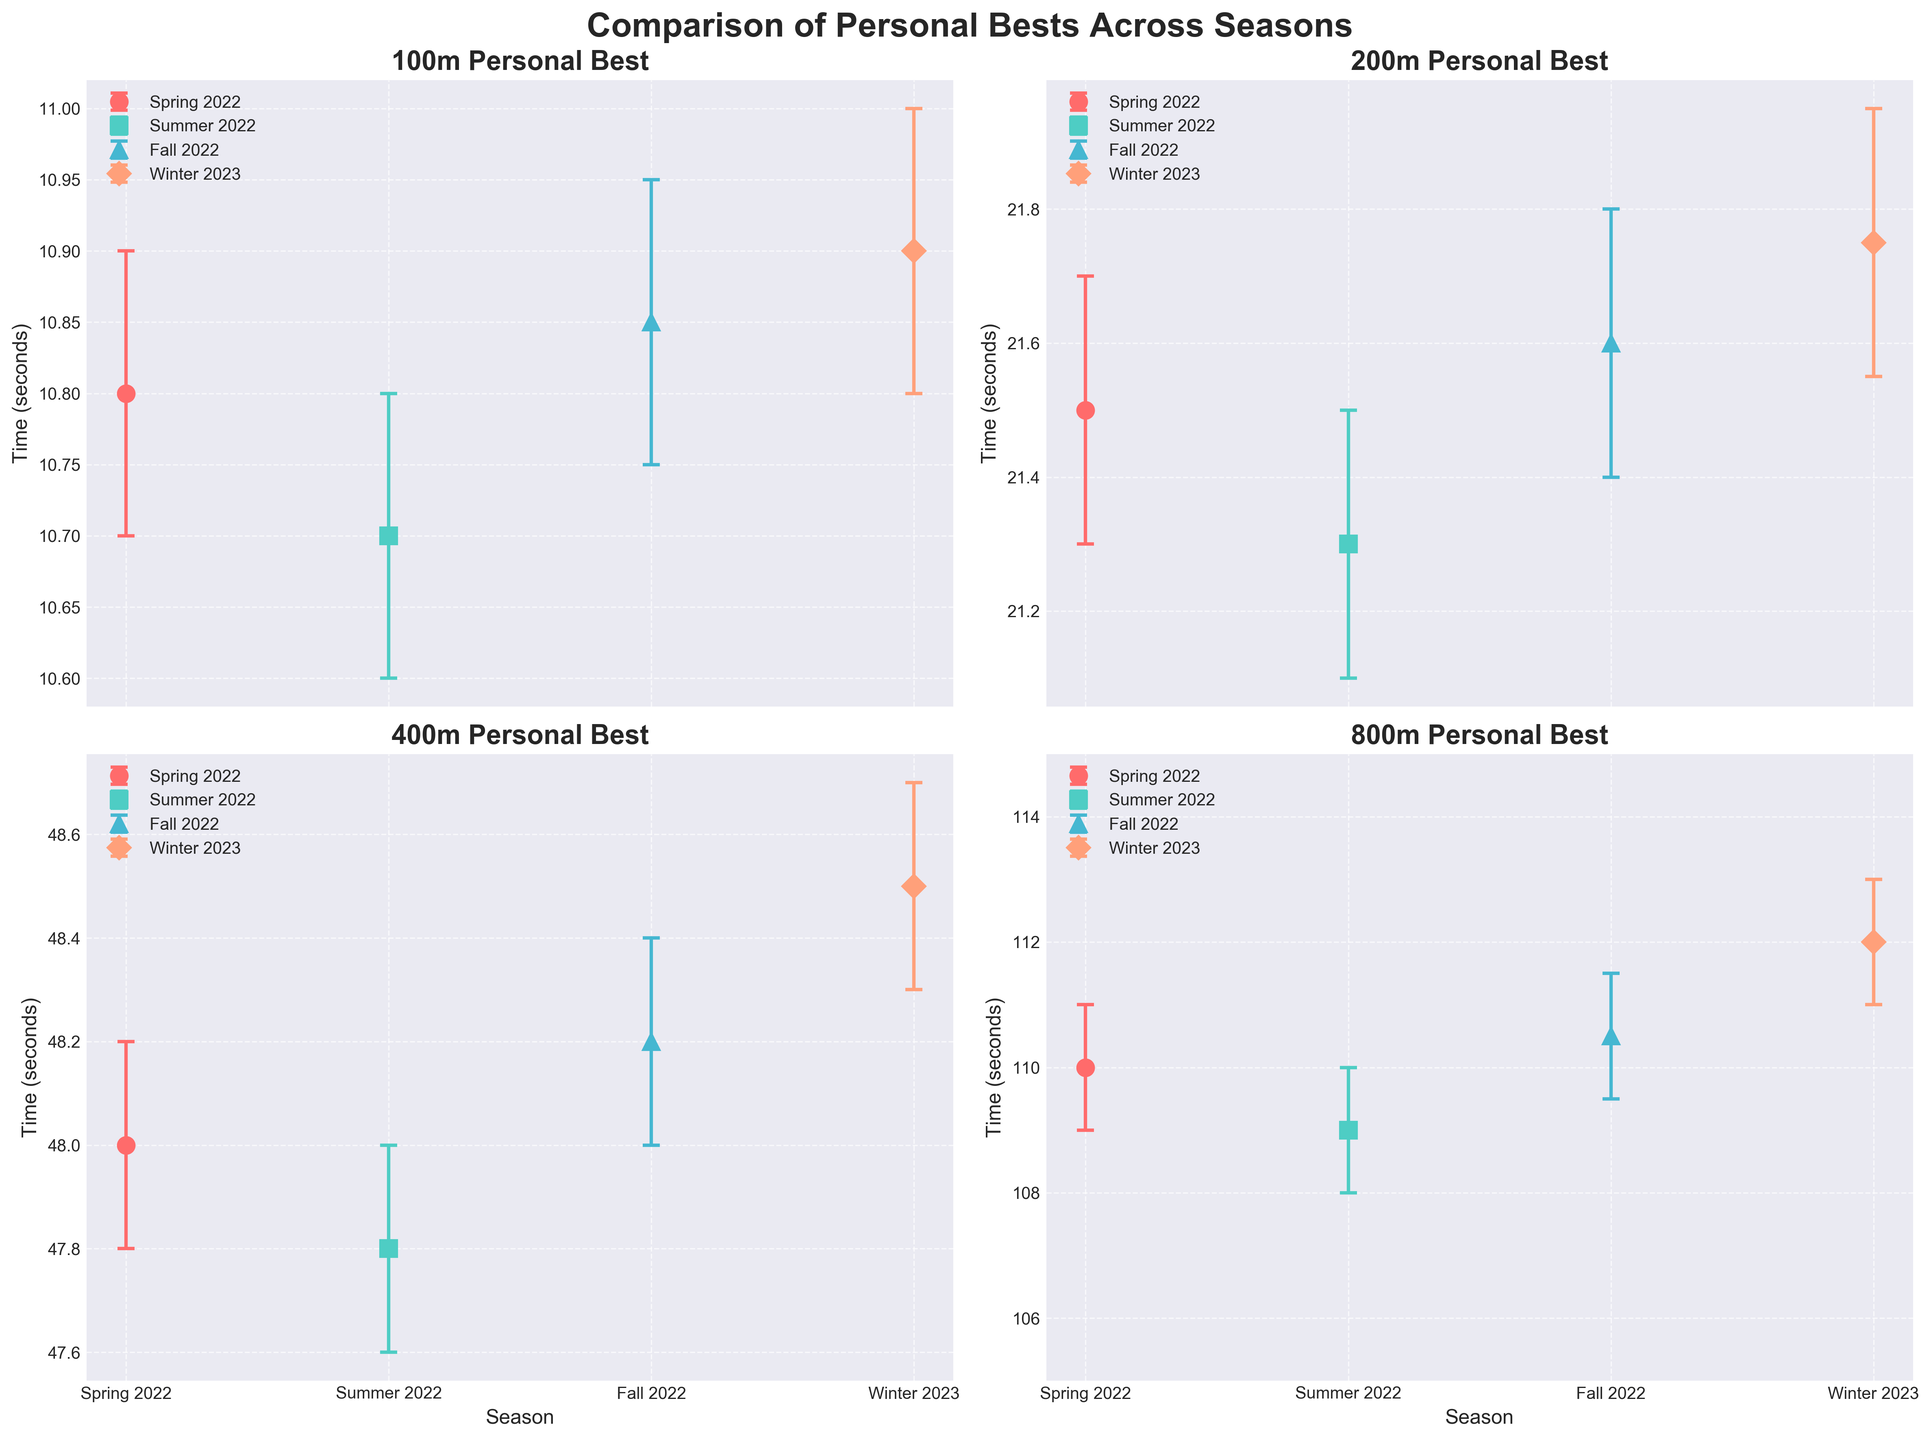What's the primary title of the figure? The main title is located above all subplots, which summarizes the content of the figure. It states 'Comparison of Personal Bests Across Seasons', reflecting the purpose of the figure which is to compare timings across different events and seasons.
Answer: Comparison of Personal Bests Across Seasons How many events are compared in the figure? Each subplot represents one event, and there are four subplots in total. Therefore, four different events are compared.
Answer: Four Which season has the best personal best time for the 200m event? By comparing the error bars and markers within the subplot for the 200m event, Summer 2022 has the lowest time at 21.30 sec, indicating the best personal best.
Answer: Summer 2022 What is the overall trend in personal best times for the 100m event from Spring 2022 to Winter 2023? Checking the 100m subplot, the personal best times slightly decrease in Summer 2022 to 10.70 sec, increase in Fall 2022 to 10.85 sec, and rise further in Winter 2023 to 10.90 sec, indicating a general worsening overtime.
Answer: Times worsening Which event shows the widest confidence interval in Winter 2023? By comparing the range of error bars for Winter 2023 in each subplot, the 800m event subplot shows the widest confidence interval with a range from 111.00 sec to 113.00 sec.
Answer: 800m For which event did the personal best time not change from Fall 2022 to Winter 2023? In the 400m event subplot, the personal best times for Fall 2022 and Winter 2023 are 48.20 sec and 48.50 sec respectively, in other events, the times generally changed except for the 400m.
Answer: 400m Among the events, which one has the most stable personal best time (smallest interval) in Summer 2022? By examining the confidence intervals in Summer 2022, the 400m event has the smallest confidence interval ranging from 47.60 sec to 48.00 sec, making it the most stable in that season.
Answer: 400m What is the time range for the personal best in the 800m event for Spring 2022? For the subplot of the 800m event, the personal best in Spring 2022 is 110.00 sec with an interval ranging from 109.00 sec to 111.00 sec.
Answer: 109.00 sec to 111.00 sec 